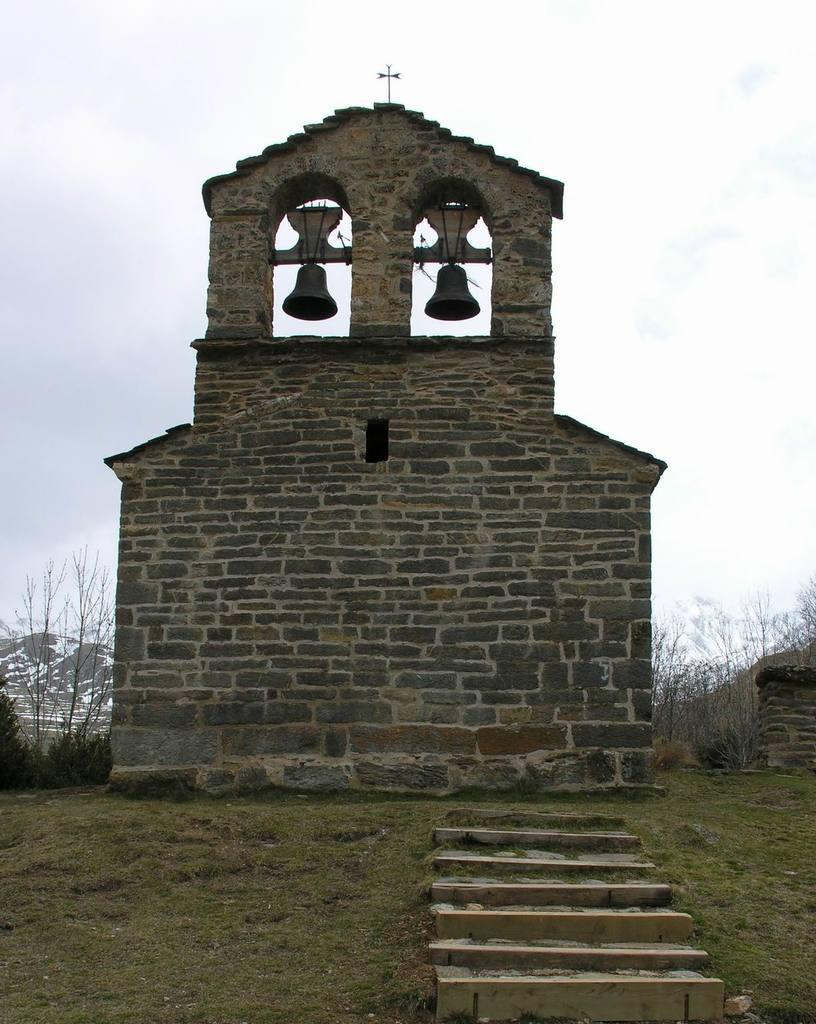What type of structure can be seen in the image? There is a wall in the image. What natural elements are present in the image? There are trees, mountains, and grass on the ground in the image. Are there any architectural features visible in the image? Yes, there are stairs in the image. What objects can be heard in the image? There are bells in the image. What is visible in the background of the image? The sky, clouds, and mountains are visible in the background of the image. How many letters did the visitor bring with them to the mountains in the image? There is no visitor or letters present in the image. What type of lizards can be seen climbing the wall in the image? There are no lizards present in the image. 